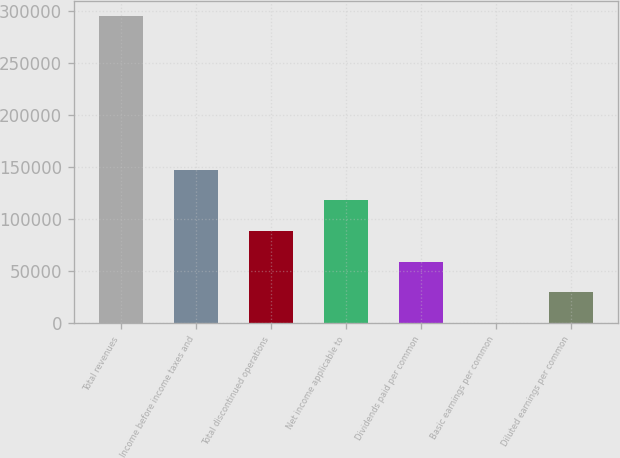Convert chart. <chart><loc_0><loc_0><loc_500><loc_500><bar_chart><fcel>Total revenues<fcel>Income before income taxes and<fcel>Total discontinued operations<fcel>Net income applicable to<fcel>Dividends paid per common<fcel>Basic earnings per common<fcel>Diluted earnings per common<nl><fcel>294946<fcel>147473<fcel>88483.9<fcel>117978<fcel>58989.3<fcel>0.14<fcel>29494.7<nl></chart> 